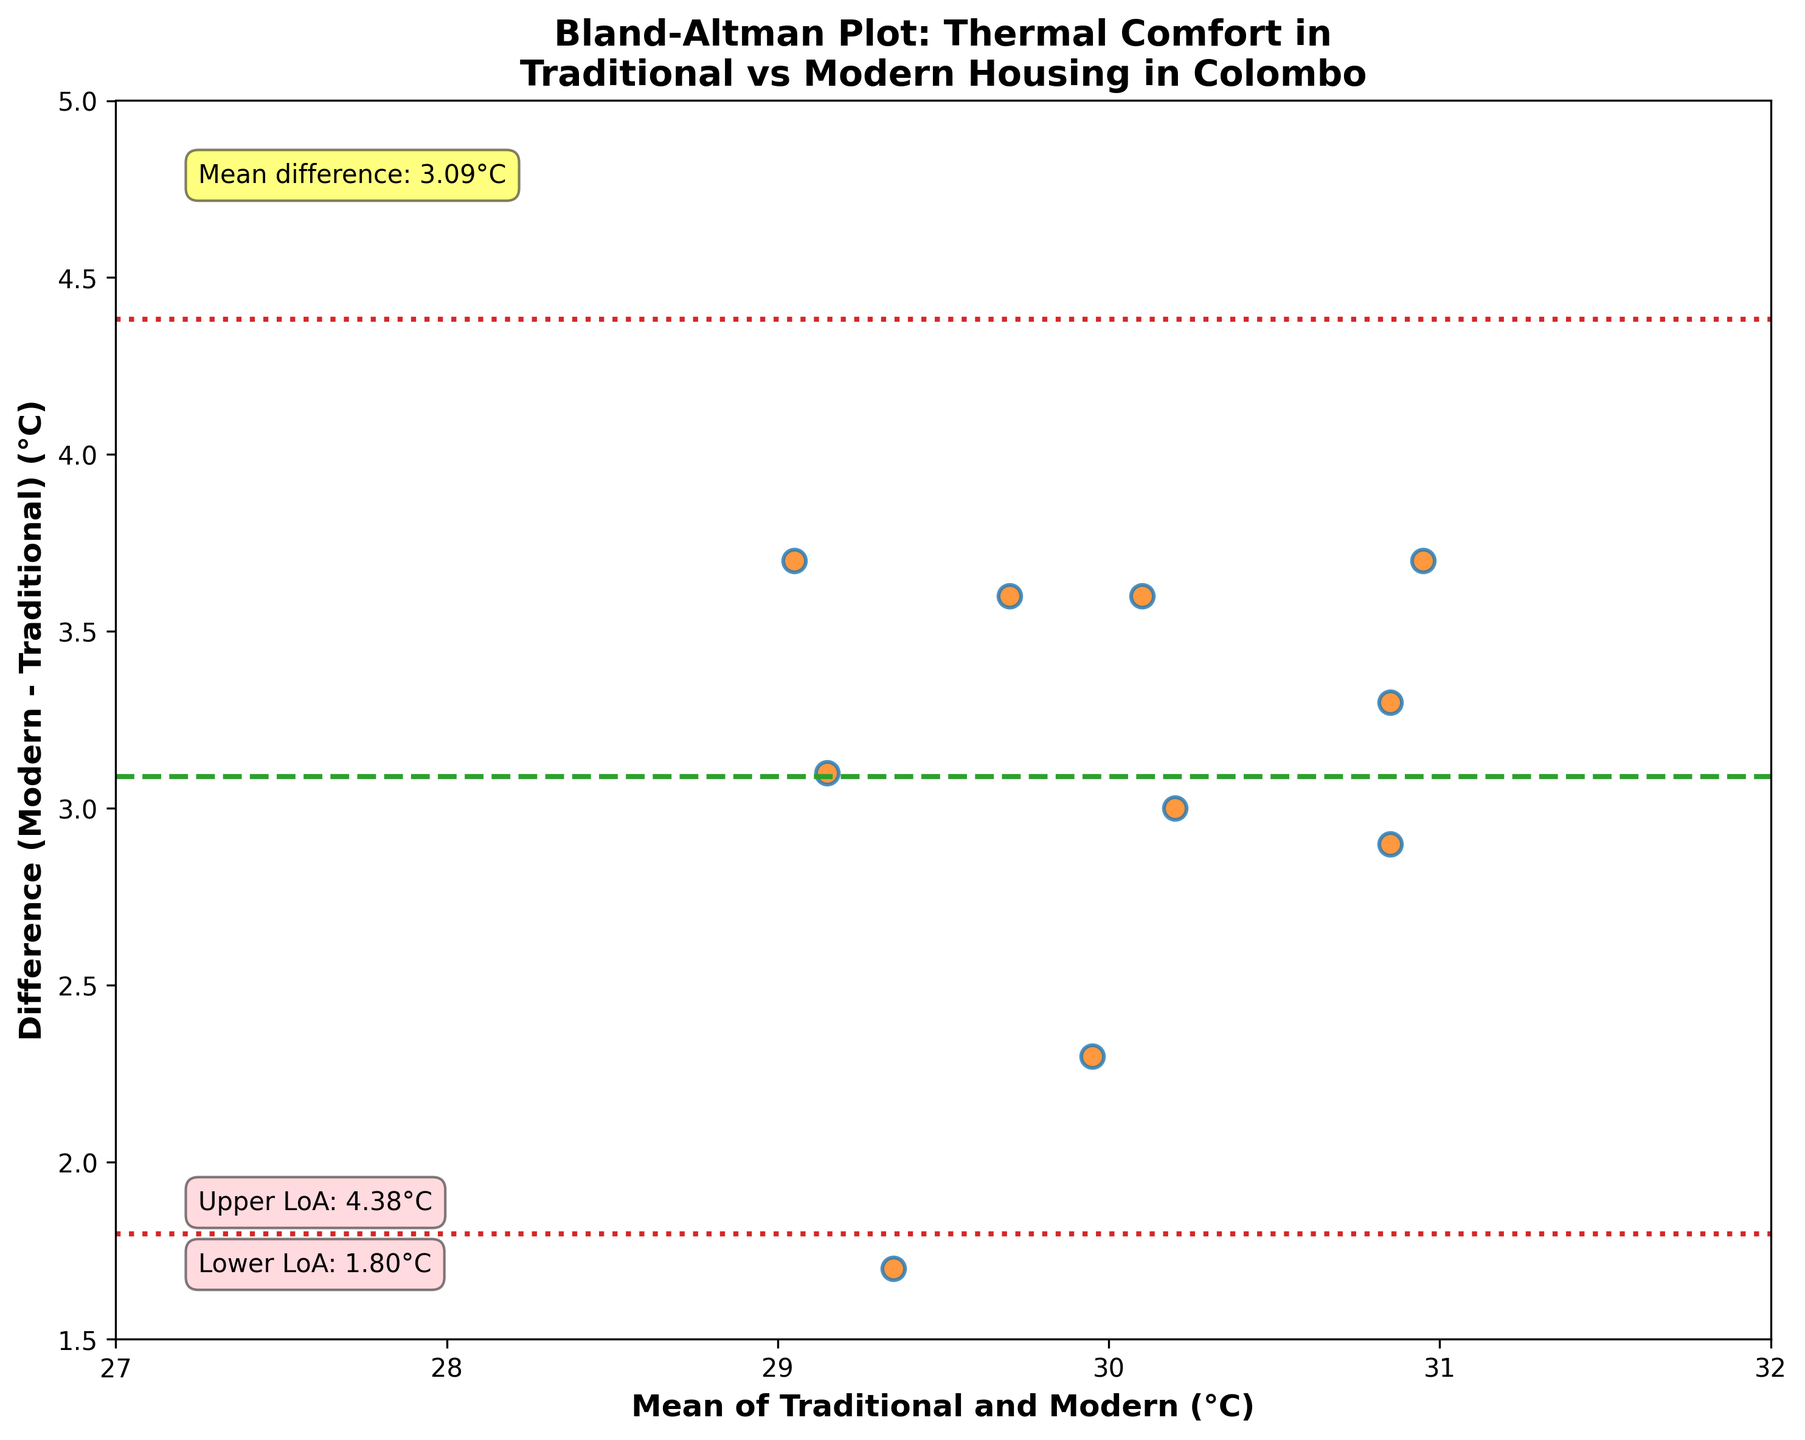What is the title of the plot? The title is usually found at the top of the plot. It gives an overview of what the plot represents. In this case, it is "Bland-Altman Plot: Thermal Comfort in Traditional vs Modern Housing in Colombo."
Answer: Bland-Altman Plot: Thermal Comfort in Traditional vs Modern Housing in Colombo What does the x-axis represent? The x-axis label usually describes what the x-axis denotes. Here, it represents the "Mean of Traditional and Modern (°C)."
Answer: Mean of Traditional and Modern (°C) What does the y-axis represent? The y-axis label usually describes what the y-axis denotes. Here, it represents the "Difference (Modern - Traditional) (°C)."
Answer: Difference (Modern - Traditional) (°C) How many data points are plotted? Each point in the scatter plot represents one data point. Here, there are 10 traditional courtyard houses and 10 modern apartment complexes, so there are 10 data points.
Answer: 10 What is the color of the data points? The color of the data points can be identified visually. Here, the data points are orange with blue edges.
Answer: Orange with blue edges What is the value of the mean difference? The mean difference is indicated by the dashed line and is annotated on the plot. Here, it reads "Mean difference: 2.93°C."
Answer: 2.93°C What is the range of the limits of agreement? The limits of agreement are represented by the dotted lines and are also annotated on the plot with values. Here, they are from 1.98°C to 3.88°C.
Answer: 1.98°C to 3.88°C What is the temperature difference between the "Niwasa in Mount Lavinia" and the "Sinhala Niwahana in Nawala"? To find temperature differences, locate the respective data points and compare their values on the y-axis. For "Niwasa in Mount Lavinia" (31.5 - 27.9) = 3.6°C and "Sinhala Niwahana in Nawala" (32.3 - 29.4) = 2.9°C. The difference is 3.6°C - 2.9°C = 0.7°C.
Answer: 0.7°C Which building has the lowest mean temperature? To determine the lowest mean temperature, calculate the mean for each building and compare. "Dutch House in Galle Face" has traditional and modern temperatures of 27.2°C and 30.9°C respectively. Mean = (27.2 + 30.9)/2 = 29.05°C, which is the lowest among the data points.
Answer: Dutch House in Galle Face Are all the differences within the limits of agreement? Check if all plotted differences between modern and traditional temperatures fall within the range of 1.98°C to 3.88°C. All points seem to fall within this range.
Answer: Yes Is there any building where the modern temperature is lower than the traditional temperature? Examine the y-axis for any negative differences (Modern - Traditional). Here, all differences are positive, indicating the modern temperature is higher for all buildings.
Answer: No 